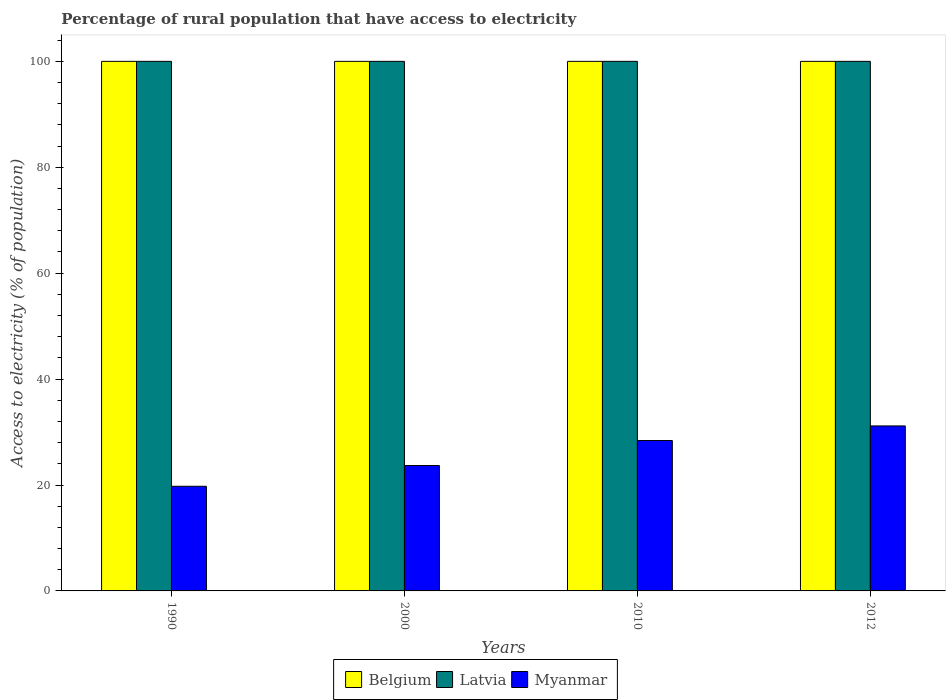How many different coloured bars are there?
Ensure brevity in your answer.  3. How many groups of bars are there?
Your answer should be compact. 4. Are the number of bars on each tick of the X-axis equal?
Ensure brevity in your answer.  Yes. How many bars are there on the 2nd tick from the right?
Your response must be concise. 3. What is the label of the 1st group of bars from the left?
Provide a short and direct response. 1990. In how many cases, is the number of bars for a given year not equal to the number of legend labels?
Give a very brief answer. 0. What is the percentage of rural population that have access to electricity in Myanmar in 1990?
Ensure brevity in your answer.  19.76. Across all years, what is the maximum percentage of rural population that have access to electricity in Belgium?
Keep it short and to the point. 100. Across all years, what is the minimum percentage of rural population that have access to electricity in Belgium?
Your answer should be compact. 100. In which year was the percentage of rural population that have access to electricity in Belgium maximum?
Keep it short and to the point. 1990. In which year was the percentage of rural population that have access to electricity in Myanmar minimum?
Give a very brief answer. 1990. What is the total percentage of rural population that have access to electricity in Belgium in the graph?
Provide a short and direct response. 400. What is the difference between the percentage of rural population that have access to electricity in Belgium in 2010 and the percentage of rural population that have access to electricity in Myanmar in 2012?
Keep it short and to the point. 68.85. What is the average percentage of rural population that have access to electricity in Latvia per year?
Ensure brevity in your answer.  100. In the year 2012, what is the difference between the percentage of rural population that have access to electricity in Latvia and percentage of rural population that have access to electricity in Myanmar?
Provide a short and direct response. 68.85. What is the ratio of the percentage of rural population that have access to electricity in Myanmar in 1990 to that in 2012?
Offer a very short reply. 0.63. Is the difference between the percentage of rural population that have access to electricity in Latvia in 1990 and 2000 greater than the difference between the percentage of rural population that have access to electricity in Myanmar in 1990 and 2000?
Give a very brief answer. Yes. What is the difference between the highest and the lowest percentage of rural population that have access to electricity in Myanmar?
Ensure brevity in your answer.  11.39. What does the 1st bar from the left in 2000 represents?
Make the answer very short. Belgium. What does the 3rd bar from the right in 1990 represents?
Make the answer very short. Belgium. How many bars are there?
Your response must be concise. 12. How many years are there in the graph?
Offer a very short reply. 4. Are the values on the major ticks of Y-axis written in scientific E-notation?
Offer a very short reply. No. Does the graph contain any zero values?
Make the answer very short. No. Where does the legend appear in the graph?
Your answer should be compact. Bottom center. How many legend labels are there?
Give a very brief answer. 3. What is the title of the graph?
Make the answer very short. Percentage of rural population that have access to electricity. What is the label or title of the Y-axis?
Your answer should be very brief. Access to electricity (% of population). What is the Access to electricity (% of population) of Myanmar in 1990?
Provide a short and direct response. 19.76. What is the Access to electricity (% of population) in Latvia in 2000?
Provide a succinct answer. 100. What is the Access to electricity (% of population) of Myanmar in 2000?
Provide a succinct answer. 23.68. What is the Access to electricity (% of population) of Myanmar in 2010?
Provide a succinct answer. 28.4. What is the Access to electricity (% of population) of Myanmar in 2012?
Offer a very short reply. 31.15. Across all years, what is the maximum Access to electricity (% of population) in Latvia?
Offer a very short reply. 100. Across all years, what is the maximum Access to electricity (% of population) of Myanmar?
Your response must be concise. 31.15. Across all years, what is the minimum Access to electricity (% of population) of Myanmar?
Your answer should be very brief. 19.76. What is the total Access to electricity (% of population) in Latvia in the graph?
Ensure brevity in your answer.  400. What is the total Access to electricity (% of population) in Myanmar in the graph?
Your response must be concise. 103. What is the difference between the Access to electricity (% of population) in Belgium in 1990 and that in 2000?
Your answer should be very brief. 0. What is the difference between the Access to electricity (% of population) in Latvia in 1990 and that in 2000?
Provide a short and direct response. 0. What is the difference between the Access to electricity (% of population) of Myanmar in 1990 and that in 2000?
Offer a very short reply. -3.92. What is the difference between the Access to electricity (% of population) in Latvia in 1990 and that in 2010?
Offer a very short reply. 0. What is the difference between the Access to electricity (% of population) in Myanmar in 1990 and that in 2010?
Provide a succinct answer. -8.64. What is the difference between the Access to electricity (% of population) of Latvia in 1990 and that in 2012?
Offer a terse response. 0. What is the difference between the Access to electricity (% of population) of Myanmar in 1990 and that in 2012?
Give a very brief answer. -11.39. What is the difference between the Access to electricity (% of population) of Myanmar in 2000 and that in 2010?
Offer a very short reply. -4.72. What is the difference between the Access to electricity (% of population) of Myanmar in 2000 and that in 2012?
Offer a terse response. -7.47. What is the difference between the Access to electricity (% of population) in Myanmar in 2010 and that in 2012?
Keep it short and to the point. -2.75. What is the difference between the Access to electricity (% of population) of Belgium in 1990 and the Access to electricity (% of population) of Latvia in 2000?
Offer a very short reply. 0. What is the difference between the Access to electricity (% of population) of Belgium in 1990 and the Access to electricity (% of population) of Myanmar in 2000?
Provide a succinct answer. 76.32. What is the difference between the Access to electricity (% of population) in Latvia in 1990 and the Access to electricity (% of population) in Myanmar in 2000?
Offer a very short reply. 76.32. What is the difference between the Access to electricity (% of population) of Belgium in 1990 and the Access to electricity (% of population) of Myanmar in 2010?
Your answer should be very brief. 71.6. What is the difference between the Access to electricity (% of population) in Latvia in 1990 and the Access to electricity (% of population) in Myanmar in 2010?
Make the answer very short. 71.6. What is the difference between the Access to electricity (% of population) in Belgium in 1990 and the Access to electricity (% of population) in Myanmar in 2012?
Keep it short and to the point. 68.85. What is the difference between the Access to electricity (% of population) in Latvia in 1990 and the Access to electricity (% of population) in Myanmar in 2012?
Give a very brief answer. 68.85. What is the difference between the Access to electricity (% of population) in Belgium in 2000 and the Access to electricity (% of population) in Myanmar in 2010?
Provide a succinct answer. 71.6. What is the difference between the Access to electricity (% of population) in Latvia in 2000 and the Access to electricity (% of population) in Myanmar in 2010?
Make the answer very short. 71.6. What is the difference between the Access to electricity (% of population) of Belgium in 2000 and the Access to electricity (% of population) of Myanmar in 2012?
Your answer should be very brief. 68.85. What is the difference between the Access to electricity (% of population) of Latvia in 2000 and the Access to electricity (% of population) of Myanmar in 2012?
Keep it short and to the point. 68.85. What is the difference between the Access to electricity (% of population) in Belgium in 2010 and the Access to electricity (% of population) in Latvia in 2012?
Make the answer very short. 0. What is the difference between the Access to electricity (% of population) in Belgium in 2010 and the Access to electricity (% of population) in Myanmar in 2012?
Offer a terse response. 68.85. What is the difference between the Access to electricity (% of population) of Latvia in 2010 and the Access to electricity (% of population) of Myanmar in 2012?
Your answer should be very brief. 68.85. What is the average Access to electricity (% of population) in Belgium per year?
Offer a very short reply. 100. What is the average Access to electricity (% of population) of Latvia per year?
Make the answer very short. 100. What is the average Access to electricity (% of population) in Myanmar per year?
Your response must be concise. 25.75. In the year 1990, what is the difference between the Access to electricity (% of population) of Belgium and Access to electricity (% of population) of Myanmar?
Your answer should be compact. 80.24. In the year 1990, what is the difference between the Access to electricity (% of population) of Latvia and Access to electricity (% of population) of Myanmar?
Ensure brevity in your answer.  80.24. In the year 2000, what is the difference between the Access to electricity (% of population) of Belgium and Access to electricity (% of population) of Latvia?
Ensure brevity in your answer.  0. In the year 2000, what is the difference between the Access to electricity (% of population) in Belgium and Access to electricity (% of population) in Myanmar?
Your answer should be very brief. 76.32. In the year 2000, what is the difference between the Access to electricity (% of population) in Latvia and Access to electricity (% of population) in Myanmar?
Offer a terse response. 76.32. In the year 2010, what is the difference between the Access to electricity (% of population) of Belgium and Access to electricity (% of population) of Myanmar?
Your answer should be compact. 71.6. In the year 2010, what is the difference between the Access to electricity (% of population) of Latvia and Access to electricity (% of population) of Myanmar?
Ensure brevity in your answer.  71.6. In the year 2012, what is the difference between the Access to electricity (% of population) of Belgium and Access to electricity (% of population) of Latvia?
Ensure brevity in your answer.  0. In the year 2012, what is the difference between the Access to electricity (% of population) of Belgium and Access to electricity (% of population) of Myanmar?
Provide a succinct answer. 68.85. In the year 2012, what is the difference between the Access to electricity (% of population) in Latvia and Access to electricity (% of population) in Myanmar?
Offer a very short reply. 68.85. What is the ratio of the Access to electricity (% of population) of Belgium in 1990 to that in 2000?
Give a very brief answer. 1. What is the ratio of the Access to electricity (% of population) of Latvia in 1990 to that in 2000?
Ensure brevity in your answer.  1. What is the ratio of the Access to electricity (% of population) in Myanmar in 1990 to that in 2000?
Make the answer very short. 0.83. What is the ratio of the Access to electricity (% of population) of Belgium in 1990 to that in 2010?
Offer a very short reply. 1. What is the ratio of the Access to electricity (% of population) in Myanmar in 1990 to that in 2010?
Ensure brevity in your answer.  0.7. What is the ratio of the Access to electricity (% of population) of Belgium in 1990 to that in 2012?
Offer a terse response. 1. What is the ratio of the Access to electricity (% of population) of Myanmar in 1990 to that in 2012?
Provide a succinct answer. 0.63. What is the ratio of the Access to electricity (% of population) of Belgium in 2000 to that in 2010?
Give a very brief answer. 1. What is the ratio of the Access to electricity (% of population) in Myanmar in 2000 to that in 2010?
Make the answer very short. 0.83. What is the ratio of the Access to electricity (% of population) in Belgium in 2000 to that in 2012?
Provide a succinct answer. 1. What is the ratio of the Access to electricity (% of population) in Latvia in 2000 to that in 2012?
Your response must be concise. 1. What is the ratio of the Access to electricity (% of population) of Myanmar in 2000 to that in 2012?
Offer a very short reply. 0.76. What is the ratio of the Access to electricity (% of population) of Myanmar in 2010 to that in 2012?
Keep it short and to the point. 0.91. What is the difference between the highest and the second highest Access to electricity (% of population) of Myanmar?
Your answer should be very brief. 2.75. What is the difference between the highest and the lowest Access to electricity (% of population) in Belgium?
Provide a succinct answer. 0. What is the difference between the highest and the lowest Access to electricity (% of population) in Myanmar?
Give a very brief answer. 11.39. 